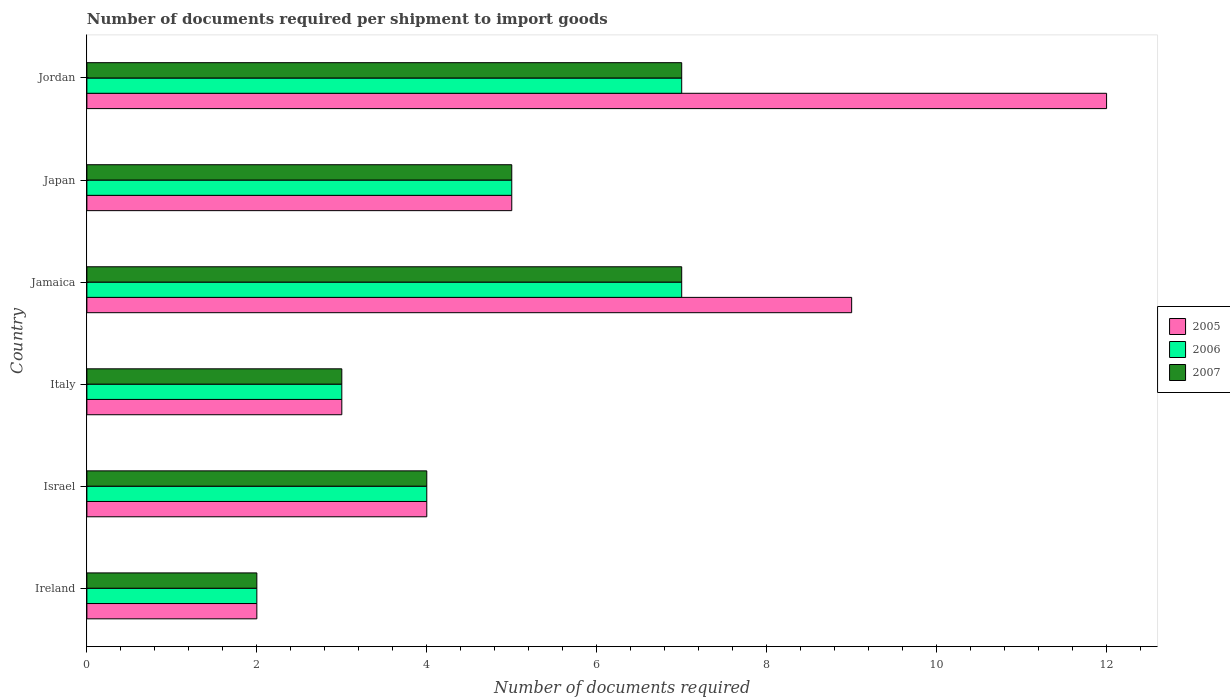Are the number of bars on each tick of the Y-axis equal?
Make the answer very short. Yes. How many bars are there on the 3rd tick from the bottom?
Make the answer very short. 3. What is the label of the 1st group of bars from the top?
Your answer should be compact. Jordan. In how many cases, is the number of bars for a given country not equal to the number of legend labels?
Ensure brevity in your answer.  0. Across all countries, what is the minimum number of documents required per shipment to import goods in 2007?
Your answer should be very brief. 2. In which country was the number of documents required per shipment to import goods in 2007 maximum?
Your answer should be very brief. Jamaica. In which country was the number of documents required per shipment to import goods in 2007 minimum?
Offer a terse response. Ireland. What is the difference between the number of documents required per shipment to import goods in 2006 in Israel and the number of documents required per shipment to import goods in 2005 in Jamaica?
Provide a succinct answer. -5. What is the average number of documents required per shipment to import goods in 2006 per country?
Offer a very short reply. 4.67. What is the difference between the number of documents required per shipment to import goods in 2007 and number of documents required per shipment to import goods in 2005 in Jamaica?
Offer a very short reply. -2. In how many countries, is the number of documents required per shipment to import goods in 2006 greater than 10 ?
Keep it short and to the point. 0. What is the ratio of the number of documents required per shipment to import goods in 2005 in Israel to that in Jamaica?
Keep it short and to the point. 0.44. Is the number of documents required per shipment to import goods in 2005 in Italy less than that in Japan?
Offer a very short reply. Yes. Is the difference between the number of documents required per shipment to import goods in 2007 in Ireland and Jordan greater than the difference between the number of documents required per shipment to import goods in 2005 in Ireland and Jordan?
Your answer should be very brief. Yes. What is the difference between the highest and the lowest number of documents required per shipment to import goods in 2007?
Provide a short and direct response. 5. In how many countries, is the number of documents required per shipment to import goods in 2007 greater than the average number of documents required per shipment to import goods in 2007 taken over all countries?
Offer a very short reply. 3. Is the sum of the number of documents required per shipment to import goods in 2005 in Ireland and Jordan greater than the maximum number of documents required per shipment to import goods in 2007 across all countries?
Provide a short and direct response. Yes. What does the 2nd bar from the bottom in Israel represents?
Offer a terse response. 2006. Is it the case that in every country, the sum of the number of documents required per shipment to import goods in 2006 and number of documents required per shipment to import goods in 2005 is greater than the number of documents required per shipment to import goods in 2007?
Keep it short and to the point. Yes. Are all the bars in the graph horizontal?
Offer a very short reply. Yes. Are the values on the major ticks of X-axis written in scientific E-notation?
Provide a succinct answer. No. Does the graph contain any zero values?
Provide a succinct answer. No. How are the legend labels stacked?
Provide a short and direct response. Vertical. What is the title of the graph?
Your response must be concise. Number of documents required per shipment to import goods. What is the label or title of the X-axis?
Give a very brief answer. Number of documents required. What is the Number of documents required in 2007 in Ireland?
Offer a very short reply. 2. What is the Number of documents required in 2005 in Israel?
Make the answer very short. 4. What is the Number of documents required of 2005 in Italy?
Your response must be concise. 3. What is the Number of documents required in 2006 in Italy?
Provide a short and direct response. 3. What is the Number of documents required of 2007 in Italy?
Offer a terse response. 3. What is the Number of documents required of 2005 in Jordan?
Offer a terse response. 12. What is the Number of documents required in 2007 in Jordan?
Provide a short and direct response. 7. Across all countries, what is the maximum Number of documents required of 2005?
Offer a very short reply. 12. Across all countries, what is the maximum Number of documents required in 2007?
Make the answer very short. 7. Across all countries, what is the minimum Number of documents required in 2005?
Your answer should be very brief. 2. What is the total Number of documents required of 2005 in the graph?
Your response must be concise. 35. What is the total Number of documents required in 2006 in the graph?
Offer a very short reply. 28. What is the difference between the Number of documents required in 2006 in Ireland and that in Italy?
Provide a succinct answer. -1. What is the difference between the Number of documents required of 2007 in Ireland and that in Italy?
Give a very brief answer. -1. What is the difference between the Number of documents required of 2006 in Ireland and that in Jamaica?
Ensure brevity in your answer.  -5. What is the difference between the Number of documents required in 2007 in Ireland and that in Jamaica?
Ensure brevity in your answer.  -5. What is the difference between the Number of documents required of 2005 in Ireland and that in Japan?
Offer a terse response. -3. What is the difference between the Number of documents required of 2006 in Ireland and that in Japan?
Your response must be concise. -3. What is the difference between the Number of documents required in 2006 in Ireland and that in Jordan?
Your answer should be compact. -5. What is the difference between the Number of documents required in 2007 in Ireland and that in Jordan?
Your answer should be very brief. -5. What is the difference between the Number of documents required of 2006 in Israel and that in Jamaica?
Your answer should be compact. -3. What is the difference between the Number of documents required of 2007 in Israel and that in Jamaica?
Make the answer very short. -3. What is the difference between the Number of documents required in 2005 in Israel and that in Japan?
Provide a short and direct response. -1. What is the difference between the Number of documents required of 2006 in Israel and that in Japan?
Ensure brevity in your answer.  -1. What is the difference between the Number of documents required in 2007 in Israel and that in Japan?
Ensure brevity in your answer.  -1. What is the difference between the Number of documents required in 2006 in Israel and that in Jordan?
Provide a succinct answer. -3. What is the difference between the Number of documents required in 2005 in Italy and that in Jamaica?
Provide a short and direct response. -6. What is the difference between the Number of documents required of 2006 in Italy and that in Jamaica?
Your answer should be very brief. -4. What is the difference between the Number of documents required of 2005 in Italy and that in Japan?
Keep it short and to the point. -2. What is the difference between the Number of documents required in 2006 in Italy and that in Japan?
Offer a very short reply. -2. What is the difference between the Number of documents required of 2005 in Italy and that in Jordan?
Provide a succinct answer. -9. What is the difference between the Number of documents required of 2005 in Jamaica and that in Japan?
Provide a short and direct response. 4. What is the difference between the Number of documents required in 2007 in Jamaica and that in Japan?
Provide a short and direct response. 2. What is the difference between the Number of documents required of 2006 in Jamaica and that in Jordan?
Keep it short and to the point. 0. What is the difference between the Number of documents required in 2005 in Japan and that in Jordan?
Your response must be concise. -7. What is the difference between the Number of documents required of 2007 in Japan and that in Jordan?
Keep it short and to the point. -2. What is the difference between the Number of documents required of 2005 in Ireland and the Number of documents required of 2007 in Israel?
Offer a terse response. -2. What is the difference between the Number of documents required in 2005 in Ireland and the Number of documents required in 2006 in Italy?
Offer a terse response. -1. What is the difference between the Number of documents required of 2005 in Ireland and the Number of documents required of 2006 in Jamaica?
Offer a terse response. -5. What is the difference between the Number of documents required in 2005 in Ireland and the Number of documents required in 2007 in Jamaica?
Provide a short and direct response. -5. What is the difference between the Number of documents required of 2005 in Ireland and the Number of documents required of 2006 in Japan?
Offer a terse response. -3. What is the difference between the Number of documents required of 2005 in Ireland and the Number of documents required of 2007 in Japan?
Keep it short and to the point. -3. What is the difference between the Number of documents required of 2006 in Ireland and the Number of documents required of 2007 in Japan?
Ensure brevity in your answer.  -3. What is the difference between the Number of documents required in 2005 in Ireland and the Number of documents required in 2006 in Jordan?
Keep it short and to the point. -5. What is the difference between the Number of documents required in 2006 in Ireland and the Number of documents required in 2007 in Jordan?
Make the answer very short. -5. What is the difference between the Number of documents required in 2005 in Israel and the Number of documents required in 2006 in Italy?
Provide a succinct answer. 1. What is the difference between the Number of documents required in 2005 in Israel and the Number of documents required in 2007 in Jamaica?
Your response must be concise. -3. What is the difference between the Number of documents required in 2005 in Israel and the Number of documents required in 2006 in Japan?
Provide a short and direct response. -1. What is the difference between the Number of documents required of 2005 in Israel and the Number of documents required of 2006 in Jordan?
Your response must be concise. -3. What is the difference between the Number of documents required in 2005 in Israel and the Number of documents required in 2007 in Jordan?
Give a very brief answer. -3. What is the difference between the Number of documents required of 2005 in Italy and the Number of documents required of 2006 in Jamaica?
Make the answer very short. -4. What is the difference between the Number of documents required of 2005 in Italy and the Number of documents required of 2006 in Japan?
Offer a very short reply. -2. What is the difference between the Number of documents required of 2005 in Italy and the Number of documents required of 2006 in Jordan?
Offer a terse response. -4. What is the difference between the Number of documents required in 2006 in Italy and the Number of documents required in 2007 in Jordan?
Provide a short and direct response. -4. What is the difference between the Number of documents required in 2005 in Jamaica and the Number of documents required in 2007 in Japan?
Your answer should be very brief. 4. What is the difference between the Number of documents required of 2006 in Jamaica and the Number of documents required of 2007 in Japan?
Make the answer very short. 2. What is the difference between the Number of documents required of 2005 in Jamaica and the Number of documents required of 2007 in Jordan?
Offer a very short reply. 2. What is the difference between the Number of documents required of 2006 in Jamaica and the Number of documents required of 2007 in Jordan?
Provide a succinct answer. 0. What is the difference between the Number of documents required of 2006 in Japan and the Number of documents required of 2007 in Jordan?
Your answer should be very brief. -2. What is the average Number of documents required in 2005 per country?
Your answer should be compact. 5.83. What is the average Number of documents required in 2006 per country?
Provide a succinct answer. 4.67. What is the average Number of documents required in 2007 per country?
Provide a succinct answer. 4.67. What is the difference between the Number of documents required of 2005 and Number of documents required of 2006 in Ireland?
Offer a terse response. 0. What is the difference between the Number of documents required in 2005 and Number of documents required in 2007 in Ireland?
Your answer should be compact. 0. What is the difference between the Number of documents required of 2006 and Number of documents required of 2007 in Ireland?
Keep it short and to the point. 0. What is the difference between the Number of documents required in 2005 and Number of documents required in 2006 in Israel?
Ensure brevity in your answer.  0. What is the difference between the Number of documents required in 2006 and Number of documents required in 2007 in Israel?
Offer a terse response. 0. What is the difference between the Number of documents required of 2005 and Number of documents required of 2006 in Jamaica?
Your answer should be very brief. 2. What is the difference between the Number of documents required in 2006 and Number of documents required in 2007 in Jamaica?
Ensure brevity in your answer.  0. What is the difference between the Number of documents required in 2005 and Number of documents required in 2007 in Jordan?
Make the answer very short. 5. What is the difference between the Number of documents required of 2006 and Number of documents required of 2007 in Jordan?
Your response must be concise. 0. What is the ratio of the Number of documents required of 2006 in Ireland to that in Israel?
Make the answer very short. 0.5. What is the ratio of the Number of documents required of 2007 in Ireland to that in Israel?
Give a very brief answer. 0.5. What is the ratio of the Number of documents required of 2005 in Ireland to that in Jamaica?
Your response must be concise. 0.22. What is the ratio of the Number of documents required in 2006 in Ireland to that in Jamaica?
Your response must be concise. 0.29. What is the ratio of the Number of documents required of 2007 in Ireland to that in Jamaica?
Give a very brief answer. 0.29. What is the ratio of the Number of documents required in 2005 in Ireland to that in Japan?
Ensure brevity in your answer.  0.4. What is the ratio of the Number of documents required in 2007 in Ireland to that in Japan?
Provide a short and direct response. 0.4. What is the ratio of the Number of documents required of 2005 in Ireland to that in Jordan?
Your answer should be compact. 0.17. What is the ratio of the Number of documents required of 2006 in Ireland to that in Jordan?
Give a very brief answer. 0.29. What is the ratio of the Number of documents required of 2007 in Ireland to that in Jordan?
Provide a short and direct response. 0.29. What is the ratio of the Number of documents required in 2007 in Israel to that in Italy?
Ensure brevity in your answer.  1.33. What is the ratio of the Number of documents required of 2005 in Israel to that in Jamaica?
Your answer should be compact. 0.44. What is the ratio of the Number of documents required of 2006 in Israel to that in Jamaica?
Provide a short and direct response. 0.57. What is the ratio of the Number of documents required of 2006 in Israel to that in Japan?
Keep it short and to the point. 0.8. What is the ratio of the Number of documents required in 2007 in Israel to that in Japan?
Provide a short and direct response. 0.8. What is the ratio of the Number of documents required of 2006 in Israel to that in Jordan?
Your response must be concise. 0.57. What is the ratio of the Number of documents required in 2007 in Israel to that in Jordan?
Give a very brief answer. 0.57. What is the ratio of the Number of documents required of 2006 in Italy to that in Jamaica?
Your answer should be very brief. 0.43. What is the ratio of the Number of documents required of 2007 in Italy to that in Jamaica?
Offer a terse response. 0.43. What is the ratio of the Number of documents required of 2005 in Italy to that in Japan?
Keep it short and to the point. 0.6. What is the ratio of the Number of documents required in 2006 in Italy to that in Japan?
Your answer should be very brief. 0.6. What is the ratio of the Number of documents required of 2005 in Italy to that in Jordan?
Your answer should be very brief. 0.25. What is the ratio of the Number of documents required of 2006 in Italy to that in Jordan?
Offer a very short reply. 0.43. What is the ratio of the Number of documents required of 2007 in Italy to that in Jordan?
Give a very brief answer. 0.43. What is the ratio of the Number of documents required in 2005 in Jamaica to that in Japan?
Give a very brief answer. 1.8. What is the ratio of the Number of documents required of 2005 in Jamaica to that in Jordan?
Ensure brevity in your answer.  0.75. What is the ratio of the Number of documents required of 2007 in Jamaica to that in Jordan?
Your answer should be very brief. 1. What is the ratio of the Number of documents required of 2005 in Japan to that in Jordan?
Offer a very short reply. 0.42. What is the ratio of the Number of documents required of 2006 in Japan to that in Jordan?
Keep it short and to the point. 0.71. What is the ratio of the Number of documents required in 2007 in Japan to that in Jordan?
Your response must be concise. 0.71. What is the difference between the highest and the second highest Number of documents required of 2007?
Keep it short and to the point. 0. What is the difference between the highest and the lowest Number of documents required of 2005?
Your answer should be very brief. 10. 